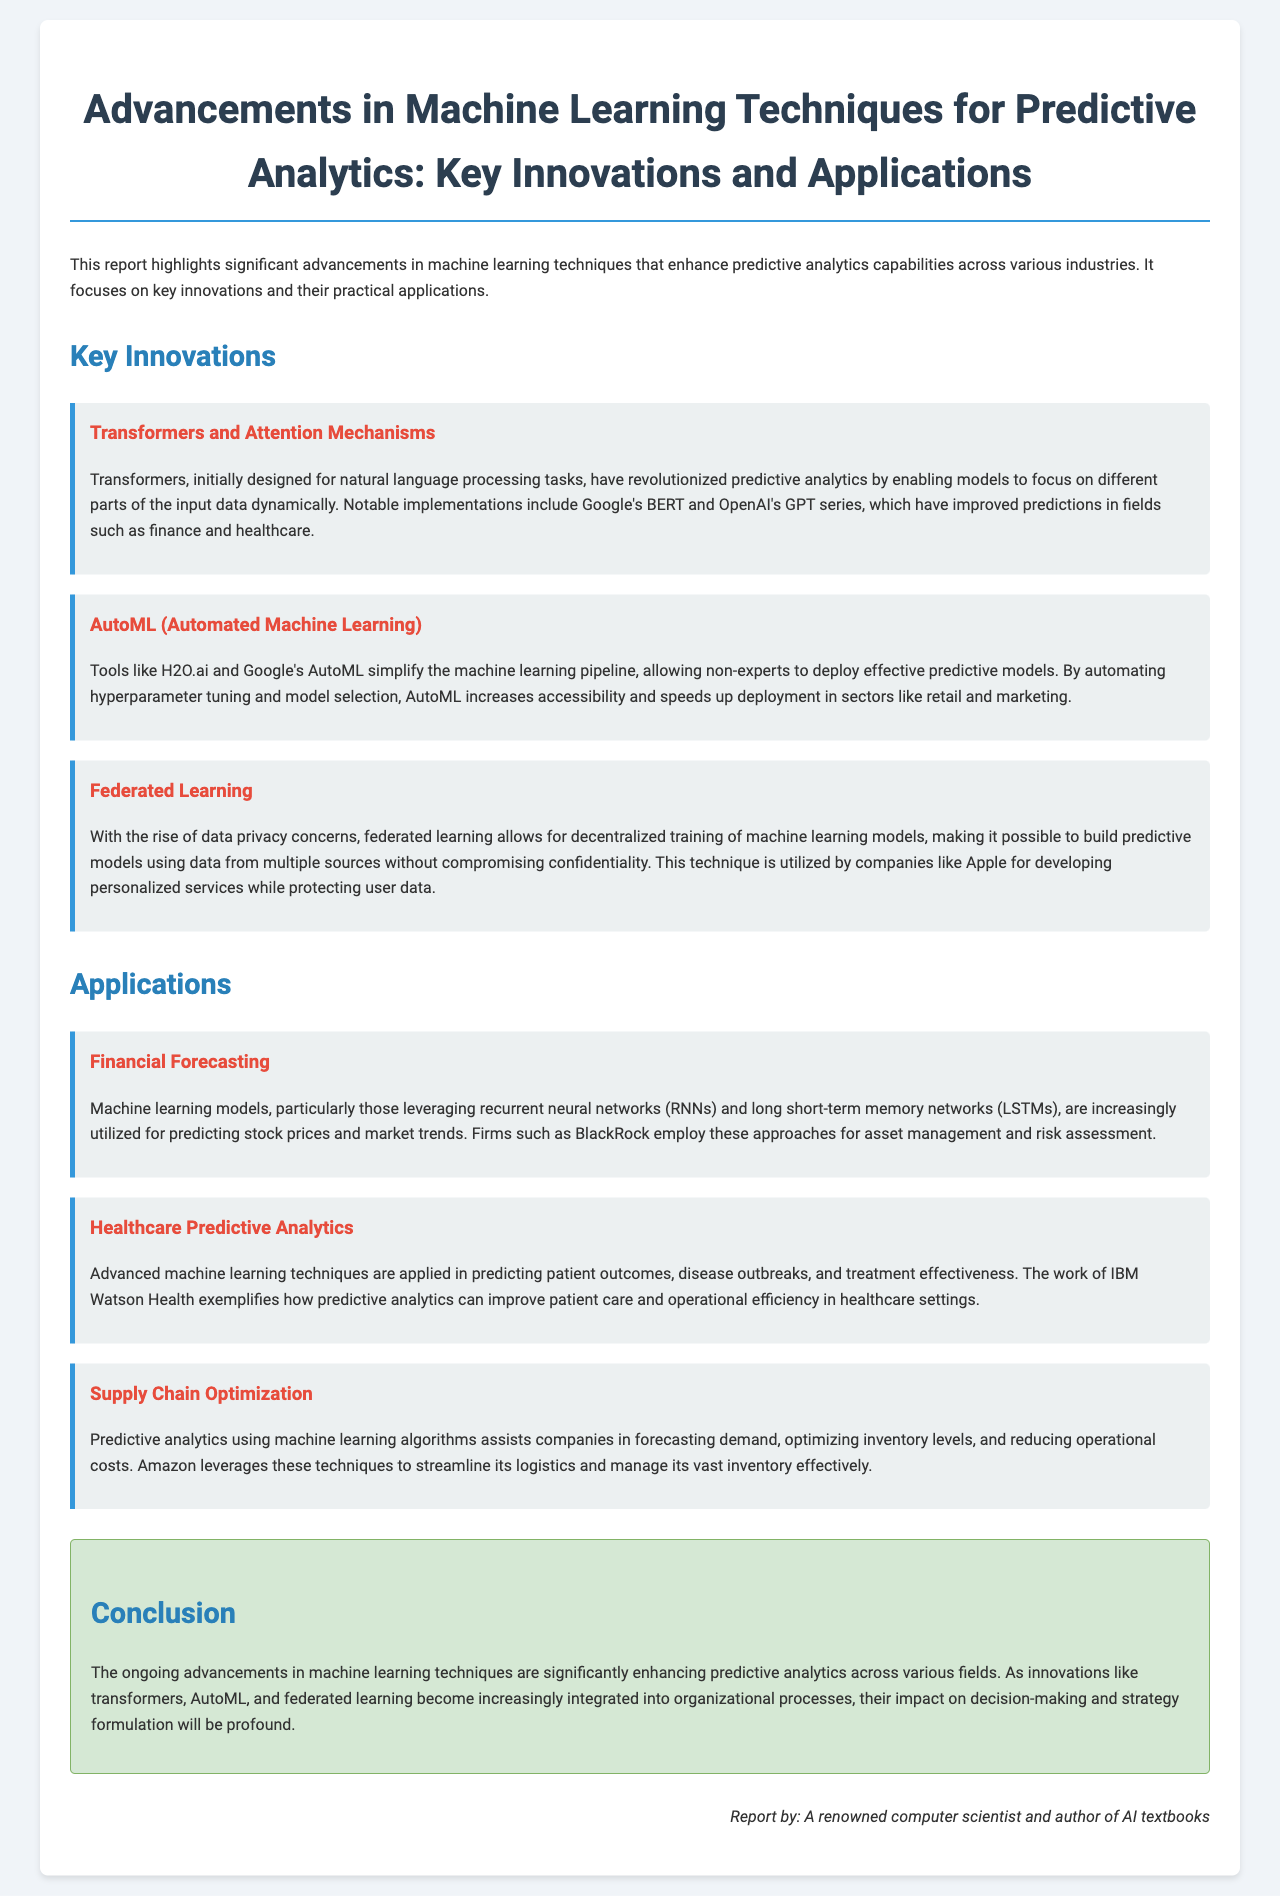What key innovation is associated with decentralized training? Federated Learning is highlighted in the document as a key innovation that allows for decentralized training of machine learning models.
Answer: Federated Learning Which company utilizes predictive analytics for asset management? The document mentions that firms like BlackRock employ machine learning models for financial forecasting, specifically in asset management.
Answer: BlackRock What is one application of AutoML mentioned in the report? The report states that AutoML tools simplify the machine learning pipeline, increasing accessibility and speeding up deployment in sectors like retail and marketing.
Answer: Retail and marketing Which technique does IBM Watson Health apply in healthcare predictive analytics? The document discusses advanced machine learning techniques for predicting patient outcomes, and IBM Watson Health is an example provider in this domain.
Answer: Predicting patient outcomes What do Transformers improve in predictive analytics? According to the report, Transformers initially designed for natural language processing tasks improve predictions in fields such as finance and healthcare.
Answer: Predictions in finance and healthcare What type of neural networks are used for stock price prediction? The report references recurrent neural networks (RNNs) and long short-term memory networks (LSTMs) as models used for predicting stock prices.
Answer: RNNs and LSTMs Which company is mentioned as leveraging predictive analytics for logistics? The document identifies Amazon as a company that uses predictive analytics to streamline its logistics and manage inventory effectively.
Answer: Amazon What is the focus of the report? The focus of the report is on highlighting significant advancements in machine learning techniques that enhance predictive analytics capabilities across various industries.
Answer: Key advancements in predictive analytics 